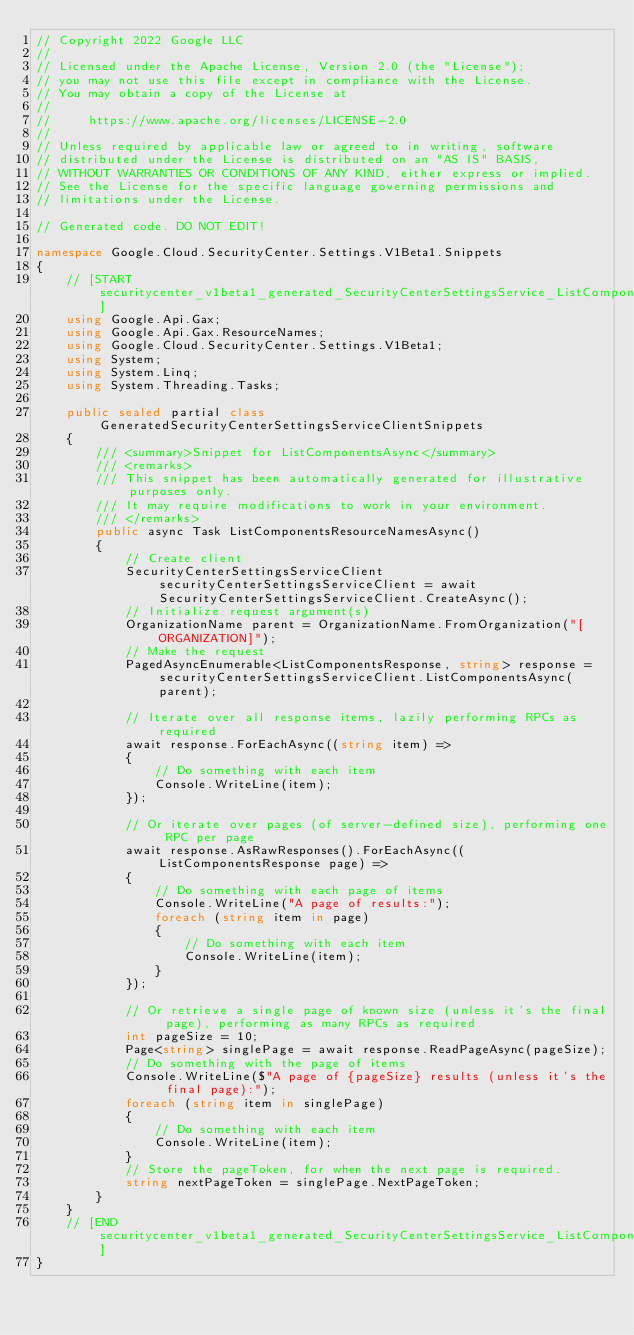<code> <loc_0><loc_0><loc_500><loc_500><_C#_>// Copyright 2022 Google LLC
//
// Licensed under the Apache License, Version 2.0 (the "License");
// you may not use this file except in compliance with the License.
// You may obtain a copy of the License at
//
//     https://www.apache.org/licenses/LICENSE-2.0
//
// Unless required by applicable law or agreed to in writing, software
// distributed under the License is distributed on an "AS IS" BASIS,
// WITHOUT WARRANTIES OR CONDITIONS OF ANY KIND, either express or implied.
// See the License for the specific language governing permissions and
// limitations under the License.

// Generated code. DO NOT EDIT!

namespace Google.Cloud.SecurityCenter.Settings.V1Beta1.Snippets
{
    // [START securitycenter_v1beta1_generated_SecurityCenterSettingsService_ListComponents_async_flattened_resourceNames]
    using Google.Api.Gax;
    using Google.Api.Gax.ResourceNames;
    using Google.Cloud.SecurityCenter.Settings.V1Beta1;
    using System;
    using System.Linq;
    using System.Threading.Tasks;

    public sealed partial class GeneratedSecurityCenterSettingsServiceClientSnippets
    {
        /// <summary>Snippet for ListComponentsAsync</summary>
        /// <remarks>
        /// This snippet has been automatically generated for illustrative purposes only.
        /// It may require modifications to work in your environment.
        /// </remarks>
        public async Task ListComponentsResourceNamesAsync()
        {
            // Create client
            SecurityCenterSettingsServiceClient securityCenterSettingsServiceClient = await SecurityCenterSettingsServiceClient.CreateAsync();
            // Initialize request argument(s)
            OrganizationName parent = OrganizationName.FromOrganization("[ORGANIZATION]");
            // Make the request
            PagedAsyncEnumerable<ListComponentsResponse, string> response = securityCenterSettingsServiceClient.ListComponentsAsync(parent);

            // Iterate over all response items, lazily performing RPCs as required
            await response.ForEachAsync((string item) =>
            {
                // Do something with each item
                Console.WriteLine(item);
            });

            // Or iterate over pages (of server-defined size), performing one RPC per page
            await response.AsRawResponses().ForEachAsync((ListComponentsResponse page) =>
            {
                // Do something with each page of items
                Console.WriteLine("A page of results:");
                foreach (string item in page)
                {
                    // Do something with each item
                    Console.WriteLine(item);
                }
            });

            // Or retrieve a single page of known size (unless it's the final page), performing as many RPCs as required
            int pageSize = 10;
            Page<string> singlePage = await response.ReadPageAsync(pageSize);
            // Do something with the page of items
            Console.WriteLine($"A page of {pageSize} results (unless it's the final page):");
            foreach (string item in singlePage)
            {
                // Do something with each item
                Console.WriteLine(item);
            }
            // Store the pageToken, for when the next page is required.
            string nextPageToken = singlePage.NextPageToken;
        }
    }
    // [END securitycenter_v1beta1_generated_SecurityCenterSettingsService_ListComponents_async_flattened_resourceNames]
}
</code> 